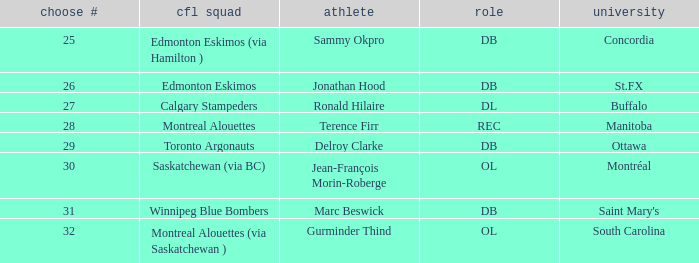Which College has a Position of ol, and a Pick # smaller than 32? Montréal. 